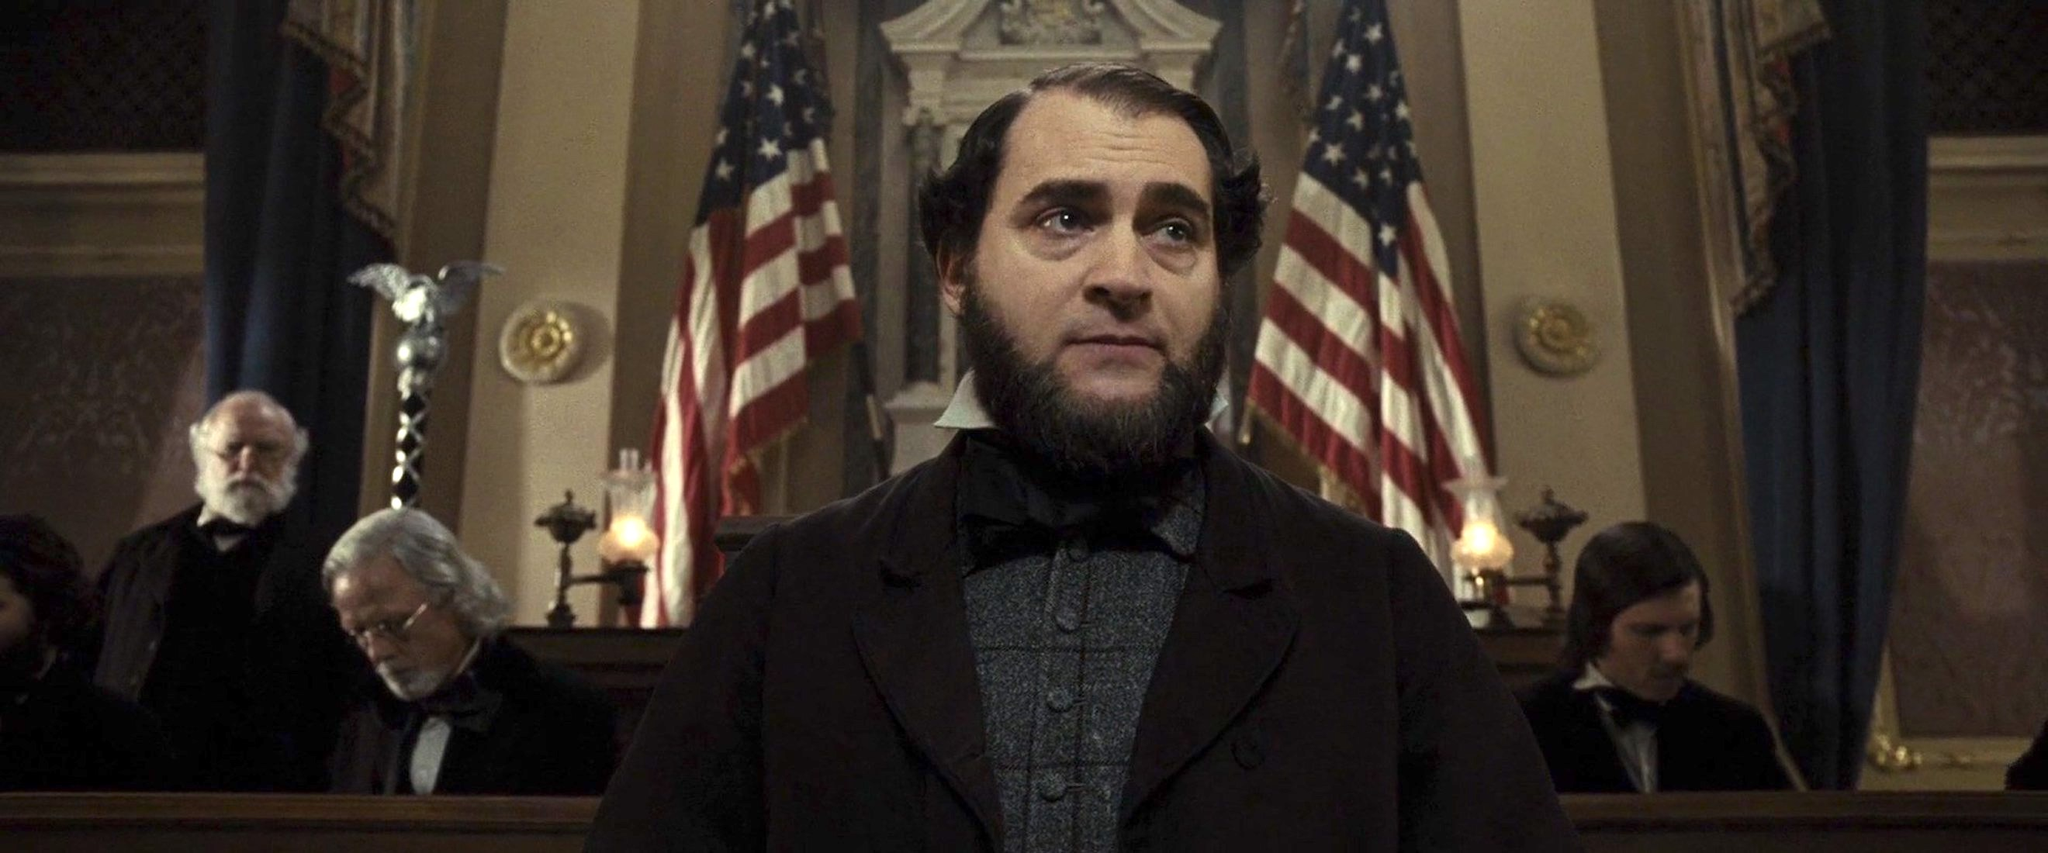What do you see happening in this image? In this image, we observe a character, likely portrayed by Michael Stuhlbarg, standing in what appears to be a historical courtroom setting. The character is positioned at a podium, framed by two prominently displayed American flags, which provide a patriotic backdrop. Dressed in period-appropriate attire, including a black suit and a somber expression, he seems deeply immersed in thought, potentially preparing to deliver an important speech or statement. The courtroom behind him is dimly lit, with other individuals present, their faces slightly out of focus, emphasizing the central figure. The atmosphere exudes a sense of gravity and historical significance. 